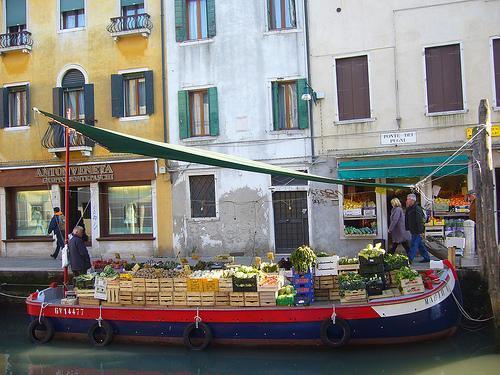How many people are buying fruits?
Give a very brief answer. 0. 